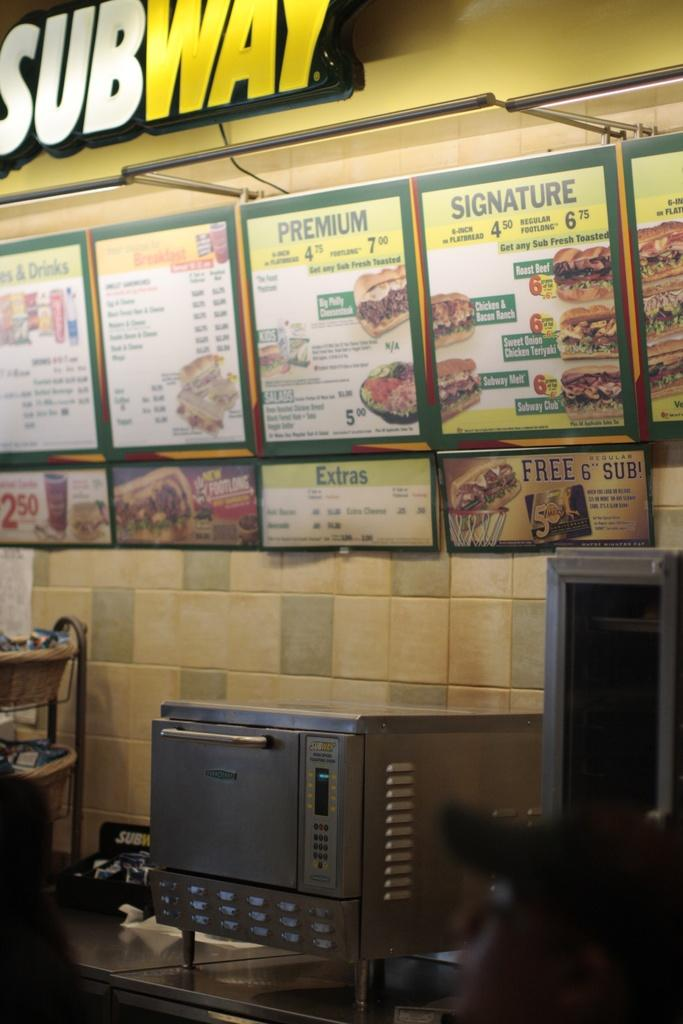<image>
Share a concise interpretation of the image provided. A subway restaurant that shows the menu and some appliances on the counter top. 